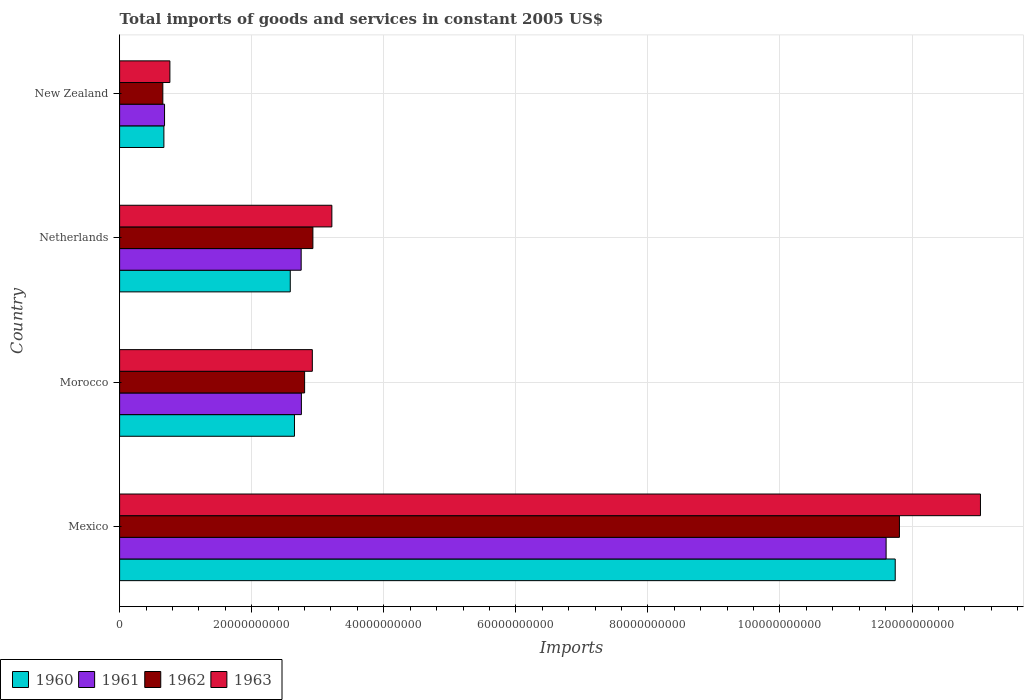How many different coloured bars are there?
Provide a short and direct response. 4. How many bars are there on the 4th tick from the top?
Give a very brief answer. 4. What is the label of the 1st group of bars from the top?
Offer a very short reply. New Zealand. In how many cases, is the number of bars for a given country not equal to the number of legend labels?
Provide a succinct answer. 0. What is the total imports of goods and services in 1961 in Mexico?
Your answer should be very brief. 1.16e+11. Across all countries, what is the maximum total imports of goods and services in 1963?
Your answer should be compact. 1.30e+11. Across all countries, what is the minimum total imports of goods and services in 1962?
Offer a very short reply. 6.55e+09. In which country was the total imports of goods and services in 1962 maximum?
Provide a succinct answer. Mexico. In which country was the total imports of goods and services in 1960 minimum?
Ensure brevity in your answer.  New Zealand. What is the total total imports of goods and services in 1962 in the graph?
Ensure brevity in your answer.  1.82e+11. What is the difference between the total imports of goods and services in 1961 in Morocco and that in Netherlands?
Provide a succinct answer. 3.12e+07. What is the difference between the total imports of goods and services in 1960 in Netherlands and the total imports of goods and services in 1961 in New Zealand?
Ensure brevity in your answer.  1.90e+1. What is the average total imports of goods and services in 1962 per country?
Give a very brief answer. 4.55e+1. What is the difference between the total imports of goods and services in 1961 and total imports of goods and services in 1963 in Netherlands?
Keep it short and to the point. -4.65e+09. What is the ratio of the total imports of goods and services in 1963 in Morocco to that in Netherlands?
Provide a succinct answer. 0.91. What is the difference between the highest and the second highest total imports of goods and services in 1963?
Keep it short and to the point. 9.82e+1. What is the difference between the highest and the lowest total imports of goods and services in 1961?
Provide a short and direct response. 1.09e+11. In how many countries, is the total imports of goods and services in 1961 greater than the average total imports of goods and services in 1961 taken over all countries?
Provide a succinct answer. 1. Is it the case that in every country, the sum of the total imports of goods and services in 1961 and total imports of goods and services in 1963 is greater than the sum of total imports of goods and services in 1960 and total imports of goods and services in 1962?
Give a very brief answer. No. What does the 1st bar from the top in Mexico represents?
Provide a succinct answer. 1963. What does the 3rd bar from the bottom in New Zealand represents?
Your answer should be very brief. 1962. Are all the bars in the graph horizontal?
Give a very brief answer. Yes. What is the difference between two consecutive major ticks on the X-axis?
Make the answer very short. 2.00e+1. Are the values on the major ticks of X-axis written in scientific E-notation?
Your answer should be compact. No. Does the graph contain any zero values?
Keep it short and to the point. No. Where does the legend appear in the graph?
Your answer should be compact. Bottom left. What is the title of the graph?
Keep it short and to the point. Total imports of goods and services in constant 2005 US$. What is the label or title of the X-axis?
Your answer should be very brief. Imports. What is the Imports in 1960 in Mexico?
Provide a short and direct response. 1.17e+11. What is the Imports of 1961 in Mexico?
Your answer should be compact. 1.16e+11. What is the Imports of 1962 in Mexico?
Give a very brief answer. 1.18e+11. What is the Imports in 1963 in Mexico?
Give a very brief answer. 1.30e+11. What is the Imports in 1960 in Morocco?
Offer a terse response. 2.65e+1. What is the Imports of 1961 in Morocco?
Ensure brevity in your answer.  2.75e+1. What is the Imports of 1962 in Morocco?
Give a very brief answer. 2.80e+1. What is the Imports in 1963 in Morocco?
Your answer should be very brief. 2.92e+1. What is the Imports of 1960 in Netherlands?
Your answer should be very brief. 2.58e+1. What is the Imports in 1961 in Netherlands?
Your answer should be compact. 2.75e+1. What is the Imports in 1962 in Netherlands?
Offer a terse response. 2.93e+1. What is the Imports in 1963 in Netherlands?
Your response must be concise. 3.21e+1. What is the Imports in 1960 in New Zealand?
Keep it short and to the point. 6.71e+09. What is the Imports in 1961 in New Zealand?
Your response must be concise. 6.81e+09. What is the Imports in 1962 in New Zealand?
Give a very brief answer. 6.55e+09. What is the Imports of 1963 in New Zealand?
Offer a very short reply. 7.62e+09. Across all countries, what is the maximum Imports of 1960?
Keep it short and to the point. 1.17e+11. Across all countries, what is the maximum Imports of 1961?
Give a very brief answer. 1.16e+11. Across all countries, what is the maximum Imports in 1962?
Offer a terse response. 1.18e+11. Across all countries, what is the maximum Imports in 1963?
Your response must be concise. 1.30e+11. Across all countries, what is the minimum Imports of 1960?
Give a very brief answer. 6.71e+09. Across all countries, what is the minimum Imports of 1961?
Provide a short and direct response. 6.81e+09. Across all countries, what is the minimum Imports of 1962?
Keep it short and to the point. 6.55e+09. Across all countries, what is the minimum Imports in 1963?
Keep it short and to the point. 7.62e+09. What is the total Imports in 1960 in the graph?
Keep it short and to the point. 1.76e+11. What is the total Imports of 1961 in the graph?
Your answer should be very brief. 1.78e+11. What is the total Imports in 1962 in the graph?
Provide a succinct answer. 1.82e+11. What is the total Imports in 1963 in the graph?
Give a very brief answer. 1.99e+11. What is the difference between the Imports of 1960 in Mexico and that in Morocco?
Your response must be concise. 9.10e+1. What is the difference between the Imports in 1961 in Mexico and that in Morocco?
Your response must be concise. 8.85e+1. What is the difference between the Imports of 1962 in Mexico and that in Morocco?
Offer a very short reply. 9.01e+1. What is the difference between the Imports in 1963 in Mexico and that in Morocco?
Your answer should be compact. 1.01e+11. What is the difference between the Imports of 1960 in Mexico and that in Netherlands?
Offer a very short reply. 9.16e+1. What is the difference between the Imports of 1961 in Mexico and that in Netherlands?
Ensure brevity in your answer.  8.86e+1. What is the difference between the Imports in 1962 in Mexico and that in Netherlands?
Make the answer very short. 8.88e+1. What is the difference between the Imports of 1963 in Mexico and that in Netherlands?
Offer a terse response. 9.82e+1. What is the difference between the Imports in 1960 in Mexico and that in New Zealand?
Your response must be concise. 1.11e+11. What is the difference between the Imports of 1961 in Mexico and that in New Zealand?
Ensure brevity in your answer.  1.09e+11. What is the difference between the Imports of 1962 in Mexico and that in New Zealand?
Your answer should be very brief. 1.12e+11. What is the difference between the Imports in 1963 in Mexico and that in New Zealand?
Offer a very short reply. 1.23e+11. What is the difference between the Imports in 1960 in Morocco and that in Netherlands?
Make the answer very short. 6.37e+08. What is the difference between the Imports in 1961 in Morocco and that in Netherlands?
Your answer should be very brief. 3.12e+07. What is the difference between the Imports in 1962 in Morocco and that in Netherlands?
Your response must be concise. -1.25e+09. What is the difference between the Imports of 1963 in Morocco and that in Netherlands?
Give a very brief answer. -2.96e+09. What is the difference between the Imports of 1960 in Morocco and that in New Zealand?
Offer a very short reply. 1.98e+1. What is the difference between the Imports in 1961 in Morocco and that in New Zealand?
Make the answer very short. 2.07e+1. What is the difference between the Imports of 1962 in Morocco and that in New Zealand?
Give a very brief answer. 2.15e+1. What is the difference between the Imports in 1963 in Morocco and that in New Zealand?
Your response must be concise. 2.16e+1. What is the difference between the Imports of 1960 in Netherlands and that in New Zealand?
Provide a succinct answer. 1.91e+1. What is the difference between the Imports in 1961 in Netherlands and that in New Zealand?
Your answer should be very brief. 2.07e+1. What is the difference between the Imports of 1962 in Netherlands and that in New Zealand?
Make the answer very short. 2.27e+1. What is the difference between the Imports in 1963 in Netherlands and that in New Zealand?
Provide a succinct answer. 2.45e+1. What is the difference between the Imports of 1960 in Mexico and the Imports of 1961 in Morocco?
Your answer should be very brief. 8.99e+1. What is the difference between the Imports of 1960 in Mexico and the Imports of 1962 in Morocco?
Keep it short and to the point. 8.94e+1. What is the difference between the Imports of 1960 in Mexico and the Imports of 1963 in Morocco?
Offer a terse response. 8.83e+1. What is the difference between the Imports of 1961 in Mexico and the Imports of 1962 in Morocco?
Make the answer very short. 8.81e+1. What is the difference between the Imports in 1961 in Mexico and the Imports in 1963 in Morocco?
Offer a terse response. 8.69e+1. What is the difference between the Imports of 1962 in Mexico and the Imports of 1963 in Morocco?
Provide a short and direct response. 8.89e+1. What is the difference between the Imports of 1960 in Mexico and the Imports of 1961 in Netherlands?
Keep it short and to the point. 9.00e+1. What is the difference between the Imports in 1960 in Mexico and the Imports in 1962 in Netherlands?
Your answer should be compact. 8.82e+1. What is the difference between the Imports in 1960 in Mexico and the Imports in 1963 in Netherlands?
Make the answer very short. 8.53e+1. What is the difference between the Imports in 1961 in Mexico and the Imports in 1962 in Netherlands?
Your answer should be very brief. 8.68e+1. What is the difference between the Imports in 1961 in Mexico and the Imports in 1963 in Netherlands?
Offer a very short reply. 8.39e+1. What is the difference between the Imports of 1962 in Mexico and the Imports of 1963 in Netherlands?
Offer a very short reply. 8.59e+1. What is the difference between the Imports in 1960 in Mexico and the Imports in 1961 in New Zealand?
Your answer should be compact. 1.11e+11. What is the difference between the Imports in 1960 in Mexico and the Imports in 1962 in New Zealand?
Give a very brief answer. 1.11e+11. What is the difference between the Imports of 1960 in Mexico and the Imports of 1963 in New Zealand?
Your answer should be compact. 1.10e+11. What is the difference between the Imports of 1961 in Mexico and the Imports of 1962 in New Zealand?
Offer a terse response. 1.10e+11. What is the difference between the Imports in 1961 in Mexico and the Imports in 1963 in New Zealand?
Ensure brevity in your answer.  1.08e+11. What is the difference between the Imports of 1962 in Mexico and the Imports of 1963 in New Zealand?
Make the answer very short. 1.10e+11. What is the difference between the Imports in 1960 in Morocco and the Imports in 1961 in Netherlands?
Your response must be concise. -1.02e+09. What is the difference between the Imports in 1960 in Morocco and the Imports in 1962 in Netherlands?
Provide a succinct answer. -2.79e+09. What is the difference between the Imports in 1960 in Morocco and the Imports in 1963 in Netherlands?
Your answer should be compact. -5.66e+09. What is the difference between the Imports in 1961 in Morocco and the Imports in 1962 in Netherlands?
Ensure brevity in your answer.  -1.74e+09. What is the difference between the Imports of 1961 in Morocco and the Imports of 1963 in Netherlands?
Offer a terse response. -4.62e+09. What is the difference between the Imports of 1962 in Morocco and the Imports of 1963 in Netherlands?
Your answer should be very brief. -4.13e+09. What is the difference between the Imports in 1960 in Morocco and the Imports in 1961 in New Zealand?
Provide a short and direct response. 1.97e+1. What is the difference between the Imports in 1960 in Morocco and the Imports in 1962 in New Zealand?
Your response must be concise. 1.99e+1. What is the difference between the Imports in 1960 in Morocco and the Imports in 1963 in New Zealand?
Offer a very short reply. 1.89e+1. What is the difference between the Imports of 1961 in Morocco and the Imports of 1962 in New Zealand?
Provide a succinct answer. 2.10e+1. What is the difference between the Imports of 1961 in Morocco and the Imports of 1963 in New Zealand?
Make the answer very short. 1.99e+1. What is the difference between the Imports of 1962 in Morocco and the Imports of 1963 in New Zealand?
Keep it short and to the point. 2.04e+1. What is the difference between the Imports in 1960 in Netherlands and the Imports in 1961 in New Zealand?
Give a very brief answer. 1.90e+1. What is the difference between the Imports of 1960 in Netherlands and the Imports of 1962 in New Zealand?
Ensure brevity in your answer.  1.93e+1. What is the difference between the Imports of 1960 in Netherlands and the Imports of 1963 in New Zealand?
Offer a terse response. 1.82e+1. What is the difference between the Imports in 1961 in Netherlands and the Imports in 1962 in New Zealand?
Give a very brief answer. 2.10e+1. What is the difference between the Imports in 1961 in Netherlands and the Imports in 1963 in New Zealand?
Ensure brevity in your answer.  1.99e+1. What is the difference between the Imports in 1962 in Netherlands and the Imports in 1963 in New Zealand?
Offer a very short reply. 2.17e+1. What is the average Imports in 1960 per country?
Ensure brevity in your answer.  4.41e+1. What is the average Imports of 1961 per country?
Give a very brief answer. 4.45e+1. What is the average Imports in 1962 per country?
Keep it short and to the point. 4.55e+1. What is the average Imports of 1963 per country?
Keep it short and to the point. 4.98e+1. What is the difference between the Imports in 1960 and Imports in 1961 in Mexico?
Make the answer very short. 1.38e+09. What is the difference between the Imports of 1960 and Imports of 1962 in Mexico?
Offer a very short reply. -6.38e+08. What is the difference between the Imports of 1960 and Imports of 1963 in Mexico?
Your response must be concise. -1.29e+1. What is the difference between the Imports in 1961 and Imports in 1962 in Mexico?
Ensure brevity in your answer.  -2.02e+09. What is the difference between the Imports in 1961 and Imports in 1963 in Mexico?
Keep it short and to the point. -1.43e+1. What is the difference between the Imports in 1962 and Imports in 1963 in Mexico?
Your answer should be very brief. -1.23e+1. What is the difference between the Imports in 1960 and Imports in 1961 in Morocco?
Keep it short and to the point. -1.05e+09. What is the difference between the Imports of 1960 and Imports of 1962 in Morocco?
Your response must be concise. -1.54e+09. What is the difference between the Imports of 1960 and Imports of 1963 in Morocco?
Your response must be concise. -2.70e+09. What is the difference between the Imports of 1961 and Imports of 1962 in Morocco?
Offer a terse response. -4.88e+08. What is the difference between the Imports of 1961 and Imports of 1963 in Morocco?
Give a very brief answer. -1.66e+09. What is the difference between the Imports in 1962 and Imports in 1963 in Morocco?
Offer a very short reply. -1.17e+09. What is the difference between the Imports in 1960 and Imports in 1961 in Netherlands?
Offer a terse response. -1.65e+09. What is the difference between the Imports in 1960 and Imports in 1962 in Netherlands?
Your answer should be compact. -3.43e+09. What is the difference between the Imports in 1960 and Imports in 1963 in Netherlands?
Your answer should be very brief. -6.30e+09. What is the difference between the Imports of 1961 and Imports of 1962 in Netherlands?
Provide a short and direct response. -1.77e+09. What is the difference between the Imports of 1961 and Imports of 1963 in Netherlands?
Make the answer very short. -4.65e+09. What is the difference between the Imports of 1962 and Imports of 1963 in Netherlands?
Provide a short and direct response. -2.87e+09. What is the difference between the Imports in 1960 and Imports in 1961 in New Zealand?
Provide a short and direct response. -9.87e+07. What is the difference between the Imports in 1960 and Imports in 1962 in New Zealand?
Give a very brief answer. 1.61e+08. What is the difference between the Imports in 1960 and Imports in 1963 in New Zealand?
Your answer should be compact. -9.09e+08. What is the difference between the Imports in 1961 and Imports in 1962 in New Zealand?
Provide a short and direct response. 2.60e+08. What is the difference between the Imports of 1961 and Imports of 1963 in New Zealand?
Your answer should be very brief. -8.10e+08. What is the difference between the Imports in 1962 and Imports in 1963 in New Zealand?
Provide a short and direct response. -1.07e+09. What is the ratio of the Imports of 1960 in Mexico to that in Morocco?
Provide a short and direct response. 4.44. What is the ratio of the Imports of 1961 in Mexico to that in Morocco?
Make the answer very short. 4.22. What is the ratio of the Imports of 1962 in Mexico to that in Morocco?
Give a very brief answer. 4.22. What is the ratio of the Imports in 1963 in Mexico to that in Morocco?
Provide a succinct answer. 4.47. What is the ratio of the Imports in 1960 in Mexico to that in Netherlands?
Provide a succinct answer. 4.54. What is the ratio of the Imports of 1961 in Mexico to that in Netherlands?
Offer a terse response. 4.22. What is the ratio of the Imports of 1962 in Mexico to that in Netherlands?
Your response must be concise. 4.03. What is the ratio of the Imports of 1963 in Mexico to that in Netherlands?
Make the answer very short. 4.06. What is the ratio of the Imports of 1960 in Mexico to that in New Zealand?
Provide a short and direct response. 17.51. What is the ratio of the Imports of 1961 in Mexico to that in New Zealand?
Offer a very short reply. 17.06. What is the ratio of the Imports in 1962 in Mexico to that in New Zealand?
Your answer should be very brief. 18.04. What is the ratio of the Imports in 1963 in Mexico to that in New Zealand?
Offer a terse response. 17.12. What is the ratio of the Imports of 1960 in Morocco to that in Netherlands?
Provide a short and direct response. 1.02. What is the ratio of the Imports in 1962 in Morocco to that in Netherlands?
Ensure brevity in your answer.  0.96. What is the ratio of the Imports in 1963 in Morocco to that in Netherlands?
Your answer should be compact. 0.91. What is the ratio of the Imports in 1960 in Morocco to that in New Zealand?
Your answer should be very brief. 3.95. What is the ratio of the Imports in 1961 in Morocco to that in New Zealand?
Your answer should be very brief. 4.04. What is the ratio of the Imports of 1962 in Morocco to that in New Zealand?
Provide a short and direct response. 4.28. What is the ratio of the Imports in 1963 in Morocco to that in New Zealand?
Your answer should be very brief. 3.83. What is the ratio of the Imports in 1960 in Netherlands to that in New Zealand?
Ensure brevity in your answer.  3.85. What is the ratio of the Imports in 1961 in Netherlands to that in New Zealand?
Give a very brief answer. 4.04. What is the ratio of the Imports in 1962 in Netherlands to that in New Zealand?
Keep it short and to the point. 4.47. What is the ratio of the Imports in 1963 in Netherlands to that in New Zealand?
Keep it short and to the point. 4.22. What is the difference between the highest and the second highest Imports in 1960?
Keep it short and to the point. 9.10e+1. What is the difference between the highest and the second highest Imports in 1961?
Make the answer very short. 8.85e+1. What is the difference between the highest and the second highest Imports in 1962?
Ensure brevity in your answer.  8.88e+1. What is the difference between the highest and the second highest Imports in 1963?
Keep it short and to the point. 9.82e+1. What is the difference between the highest and the lowest Imports in 1960?
Give a very brief answer. 1.11e+11. What is the difference between the highest and the lowest Imports of 1961?
Offer a terse response. 1.09e+11. What is the difference between the highest and the lowest Imports in 1962?
Offer a terse response. 1.12e+11. What is the difference between the highest and the lowest Imports in 1963?
Offer a terse response. 1.23e+11. 